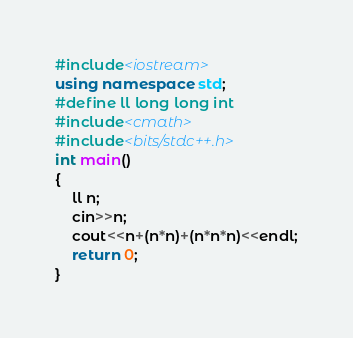<code> <loc_0><loc_0><loc_500><loc_500><_C++_>#include<iostream>
using namespace std;
#define ll long long int
#include<cmath>
#include<bits/stdc++.h>
int main()
{
	ll n;
	cin>>n;
	cout<<n+(n*n)+(n*n*n)<<endl;
	return 0;
}</code> 